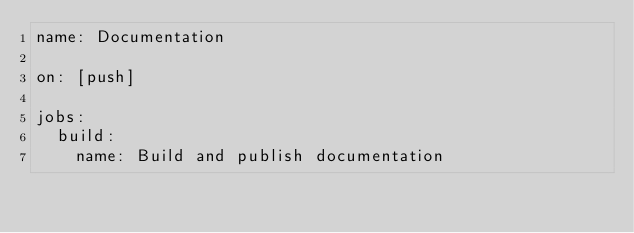<code> <loc_0><loc_0><loc_500><loc_500><_YAML_>name: Documentation

on: [push]

jobs:
  build:
    name: Build and publish documentation</code> 